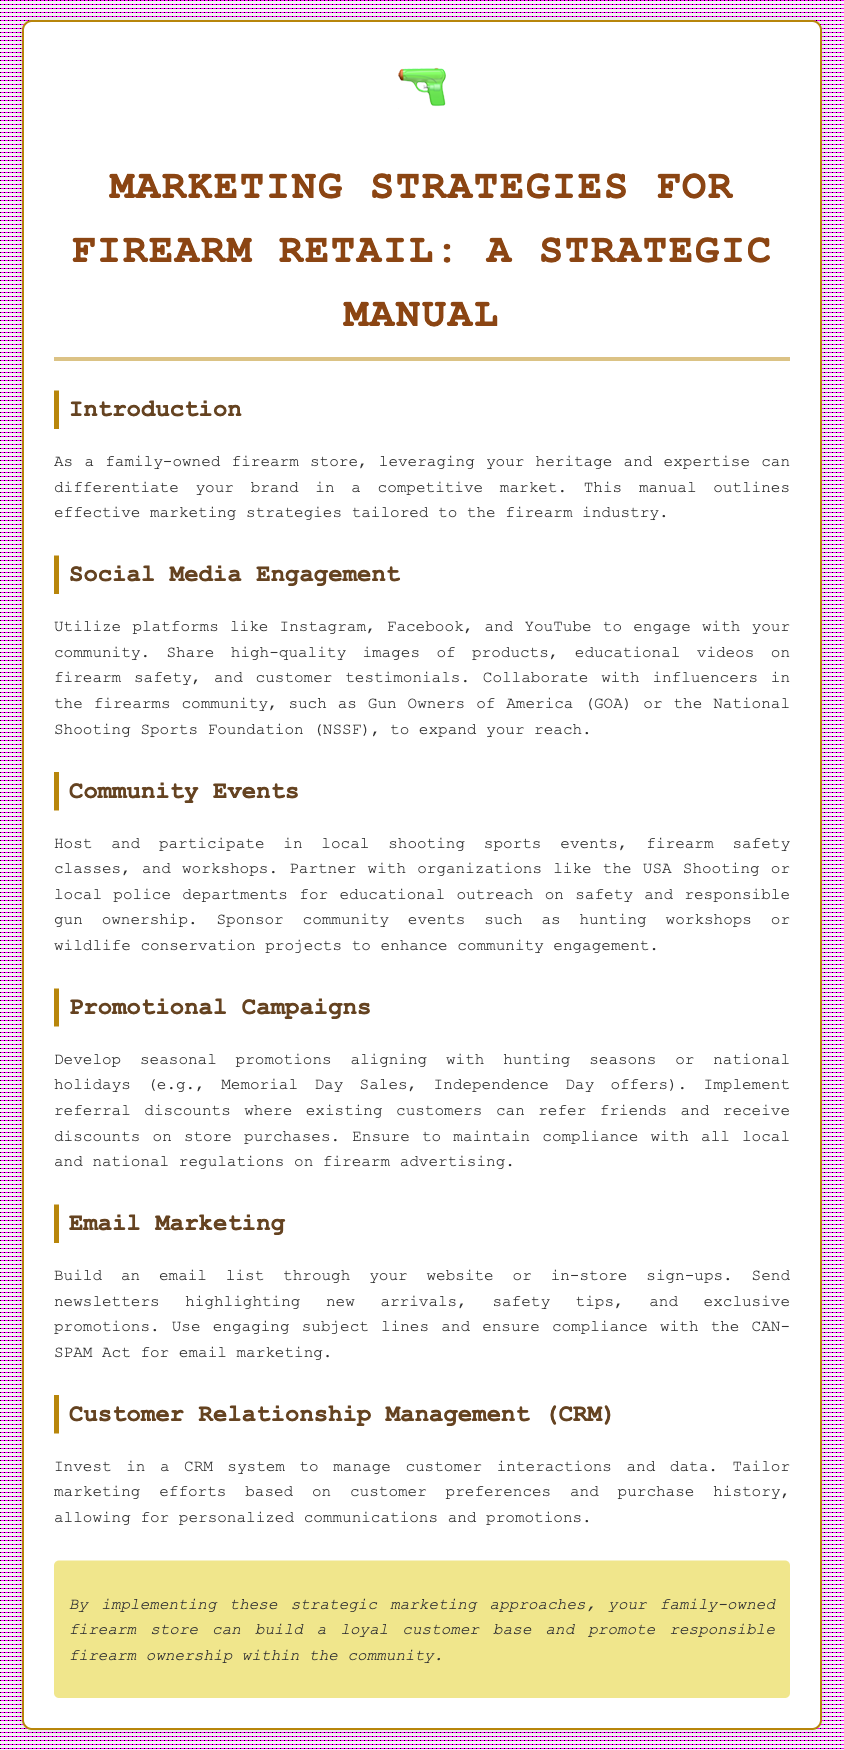what is the title of the manual? The title is prominently displayed as the main heading of the document.
Answer: Marketing Strategies for Firearm Retail: A Strategic Manual what is one platform suggested for social media engagement? The document mentions specific platforms for engagement within the Social Media Engagement section.
Answer: Instagram which organization is recommended for influencer collaboration? The document lists organizations within the Social Media Engagement section that can help expand reach.
Answer: Gun Owners of America what is a community event suggested in the manual? Community events are detailed in their respective section, giving examples of suggested activities.
Answer: Firearm safety classes what type of marketing is described involving emails? The manual clearly outlines various marketing strategies and mentions this approach in a dedicated section.
Answer: Email Marketing what is the recommended action for developing seasonal promotions? The manual suggests a specific approach related to timing in the Promotional Campaign section.
Answer: Aligning with hunting seasons how should customer interactions be managed according to the manual? The document describes a specific system used in the Customer Relationship Management section.
Answer: CRM system what should be included in newsletters sent through email marketing? The manual outlines characteristics of effective newsletters in the Email Marketing section.
Answer: New arrivals what is one benefit of investing in a CRM system? The manual explains advantages in the Customer Relationship Management section.
Answer: Personalized communications 